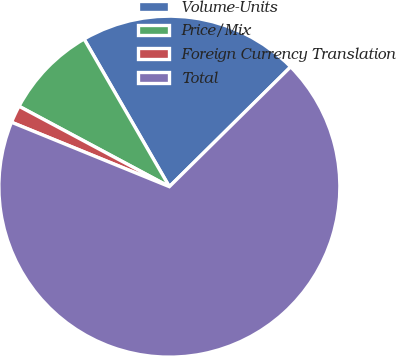Convert chart to OTSL. <chart><loc_0><loc_0><loc_500><loc_500><pie_chart><fcel>Volume-Units<fcel>Price/Mix<fcel>Foreign Currency Translation<fcel>Total<nl><fcel>20.93%<fcel>8.85%<fcel>1.65%<fcel>68.57%<nl></chart> 